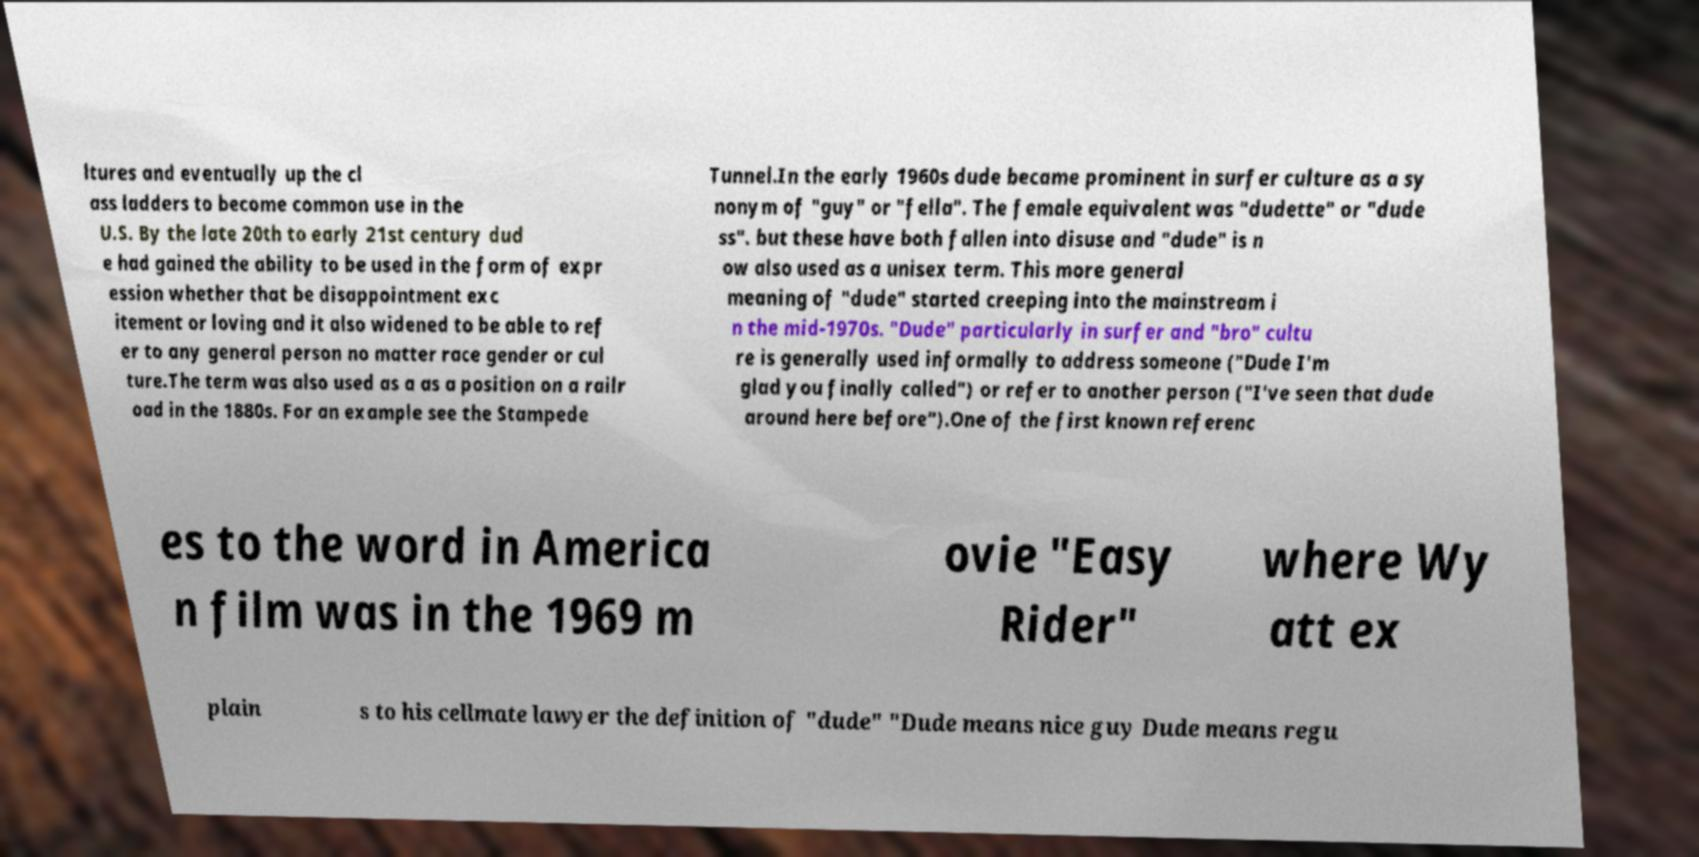What messages or text are displayed in this image? I need them in a readable, typed format. ltures and eventually up the cl ass ladders to become common use in the U.S. By the late 20th to early 21st century dud e had gained the ability to be used in the form of expr ession whether that be disappointment exc itement or loving and it also widened to be able to ref er to any general person no matter race gender or cul ture.The term was also used as a as a position on a railr oad in the 1880s. For an example see the Stampede Tunnel.In the early 1960s dude became prominent in surfer culture as a sy nonym of "guy" or "fella". The female equivalent was "dudette" or "dude ss". but these have both fallen into disuse and "dude" is n ow also used as a unisex term. This more general meaning of "dude" started creeping into the mainstream i n the mid-1970s. "Dude" particularly in surfer and "bro" cultu re is generally used informally to address someone ("Dude I'm glad you finally called") or refer to another person ("I've seen that dude around here before").One of the first known referenc es to the word in America n film was in the 1969 m ovie "Easy Rider" where Wy att ex plain s to his cellmate lawyer the definition of "dude" "Dude means nice guy Dude means regu 